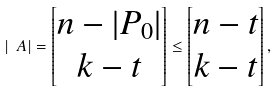Convert formula to latex. <formula><loc_0><loc_0><loc_500><loc_500>| \ A | = \left [ \begin{matrix} n - | P _ { 0 } | \\ k - t \end{matrix} \right ] \leq \left [ \begin{matrix} n - t \\ k - t \end{matrix} \right ] ,</formula> 